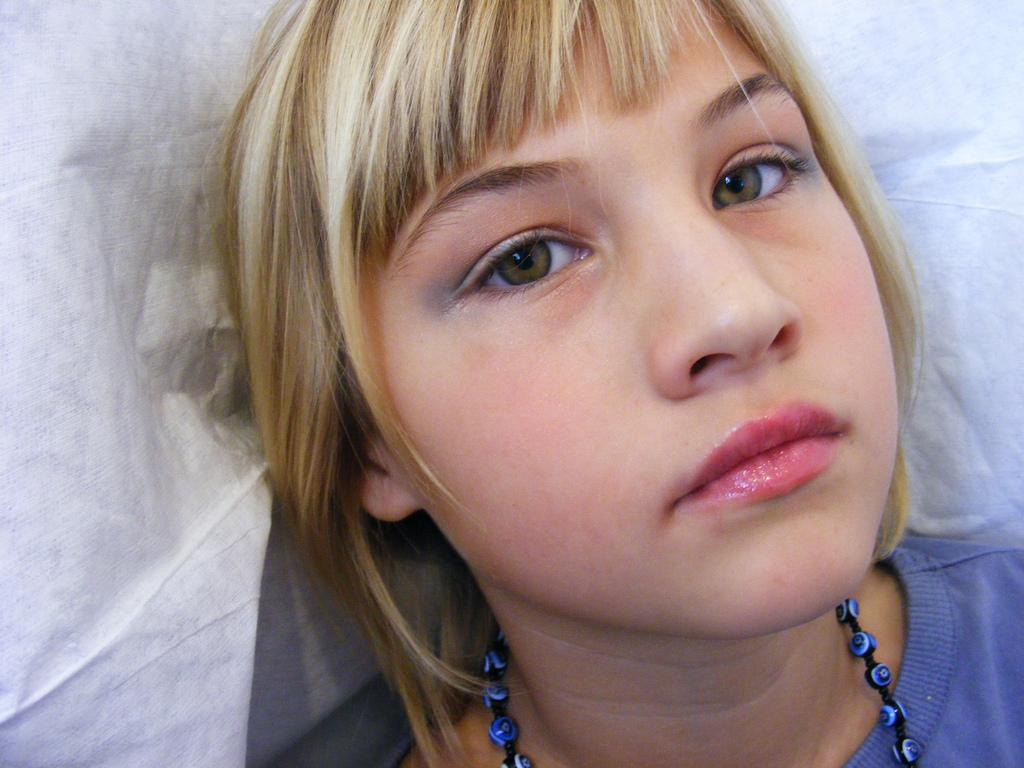Who is the main subject in the image? There is a girl in the image. What color is the background of the image? The background of the image is white in color. What type of corn can be seen growing in the image? There is no corn present in the image; it only features a girl and a white background. How is the string used in the image? There is no string present in the image. 